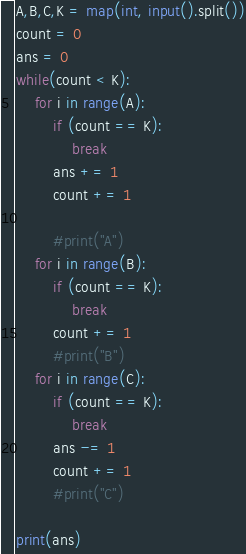Convert code to text. <code><loc_0><loc_0><loc_500><loc_500><_Python_>A,B,C,K = map(int, input().split())
count = 0
ans = 0
while(count < K):
    for i in range(A):
        if (count == K):
            break
        ans += 1
        count += 1

        #print("A")
    for i in range(B):
        if (count == K):
            break
        count += 1
        #print("B")
    for i in range(C):
        if (count == K):
            break
        ans -= 1
        count += 1
        #print("C")

print(ans)</code> 